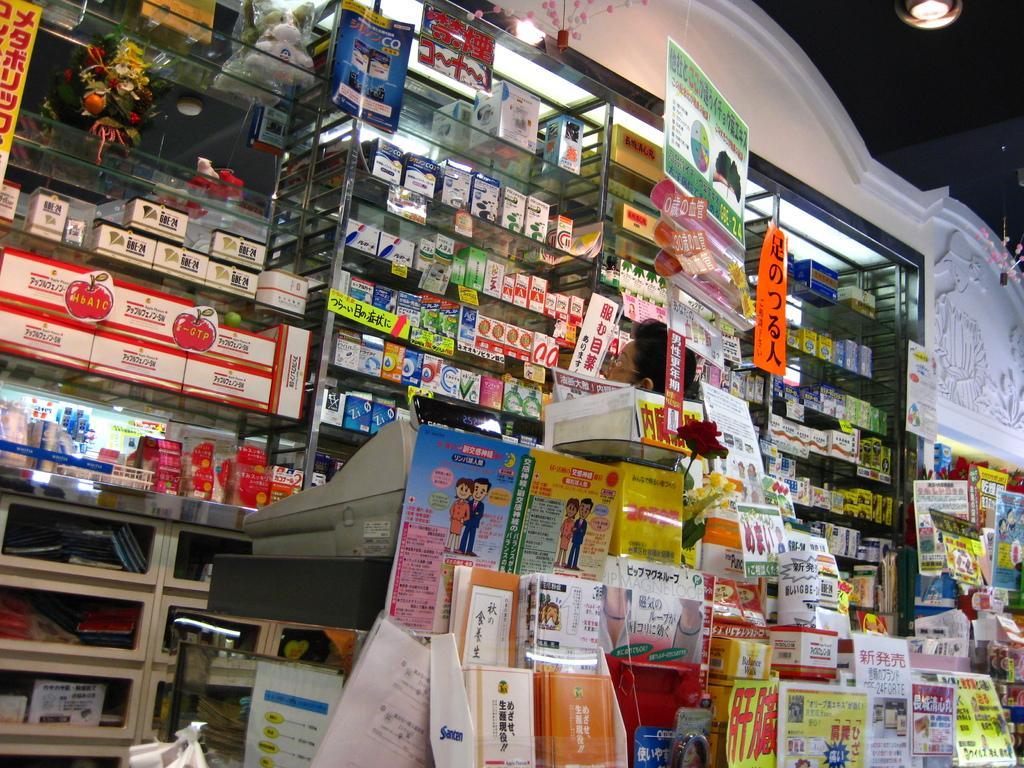Please provide a concise description of this image. In the picture it looks like some store and there are a lot of items kept in that store, at the center there is a machine kept on a table, behind that machine there is a person. 